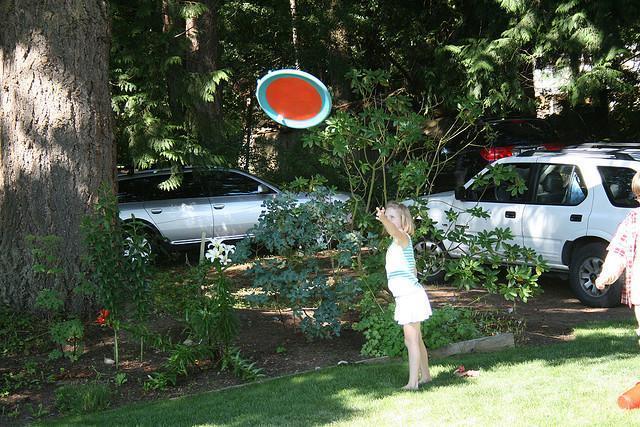How many people are there?
Give a very brief answer. 2. How many cars are there?
Give a very brief answer. 2. 